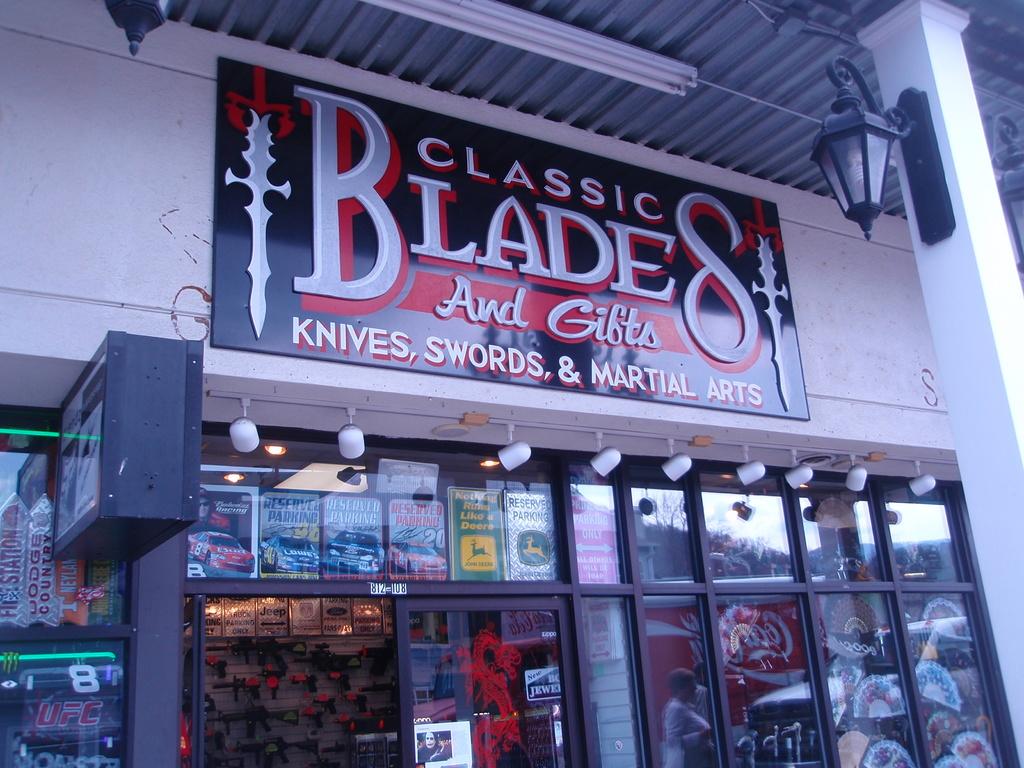What is being sold in this store?
Your answer should be compact. Knives, swords & martial arts. 